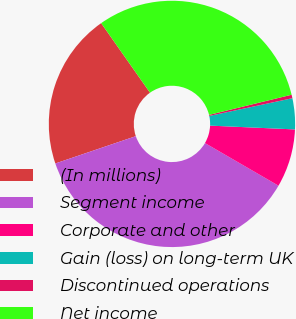<chart> <loc_0><loc_0><loc_500><loc_500><pie_chart><fcel>(In millions)<fcel>Segment income<fcel>Corporate and other<fcel>Gain (loss) on long-term UK<fcel>Discontinued operations<fcel>Net income<nl><fcel>20.46%<fcel>36.43%<fcel>7.65%<fcel>4.06%<fcel>0.46%<fcel>30.94%<nl></chart> 